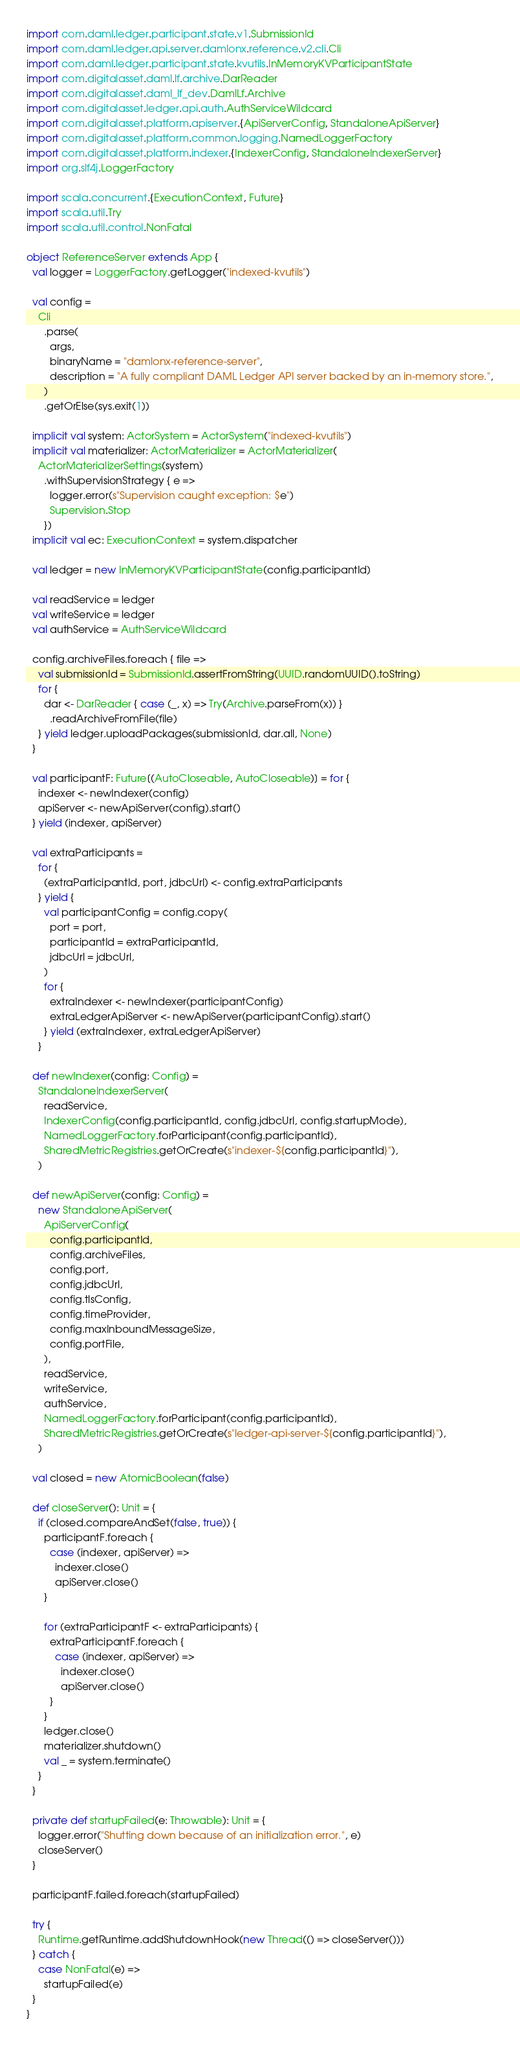Convert code to text. <code><loc_0><loc_0><loc_500><loc_500><_Scala_>import com.daml.ledger.participant.state.v1.SubmissionId
import com.daml.ledger.api.server.damlonx.reference.v2.cli.Cli
import com.daml.ledger.participant.state.kvutils.InMemoryKVParticipantState
import com.digitalasset.daml.lf.archive.DarReader
import com.digitalasset.daml_lf_dev.DamlLf.Archive
import com.digitalasset.ledger.api.auth.AuthServiceWildcard
import com.digitalasset.platform.apiserver.{ApiServerConfig, StandaloneApiServer}
import com.digitalasset.platform.common.logging.NamedLoggerFactory
import com.digitalasset.platform.indexer.{IndexerConfig, StandaloneIndexerServer}
import org.slf4j.LoggerFactory

import scala.concurrent.{ExecutionContext, Future}
import scala.util.Try
import scala.util.control.NonFatal

object ReferenceServer extends App {
  val logger = LoggerFactory.getLogger("indexed-kvutils")

  val config =
    Cli
      .parse(
        args,
        binaryName = "damlonx-reference-server",
        description = "A fully compliant DAML Ledger API server backed by an in-memory store.",
      )
      .getOrElse(sys.exit(1))

  implicit val system: ActorSystem = ActorSystem("indexed-kvutils")
  implicit val materializer: ActorMaterializer = ActorMaterializer(
    ActorMaterializerSettings(system)
      .withSupervisionStrategy { e =>
        logger.error(s"Supervision caught exception: $e")
        Supervision.Stop
      })
  implicit val ec: ExecutionContext = system.dispatcher

  val ledger = new InMemoryKVParticipantState(config.participantId)

  val readService = ledger
  val writeService = ledger
  val authService = AuthServiceWildcard

  config.archiveFiles.foreach { file =>
    val submissionId = SubmissionId.assertFromString(UUID.randomUUID().toString)
    for {
      dar <- DarReader { case (_, x) => Try(Archive.parseFrom(x)) }
        .readArchiveFromFile(file)
    } yield ledger.uploadPackages(submissionId, dar.all, None)
  }

  val participantF: Future[(AutoCloseable, AutoCloseable)] = for {
    indexer <- newIndexer(config)
    apiServer <- newApiServer(config).start()
  } yield (indexer, apiServer)

  val extraParticipants =
    for {
      (extraParticipantId, port, jdbcUrl) <- config.extraParticipants
    } yield {
      val participantConfig = config.copy(
        port = port,
        participantId = extraParticipantId,
        jdbcUrl = jdbcUrl,
      )
      for {
        extraIndexer <- newIndexer(participantConfig)
        extraLedgerApiServer <- newApiServer(participantConfig).start()
      } yield (extraIndexer, extraLedgerApiServer)
    }

  def newIndexer(config: Config) =
    StandaloneIndexerServer(
      readService,
      IndexerConfig(config.participantId, config.jdbcUrl, config.startupMode),
      NamedLoggerFactory.forParticipant(config.participantId),
      SharedMetricRegistries.getOrCreate(s"indexer-${config.participantId}"),
    )

  def newApiServer(config: Config) =
    new StandaloneApiServer(
      ApiServerConfig(
        config.participantId,
        config.archiveFiles,
        config.port,
        config.jdbcUrl,
        config.tlsConfig,
        config.timeProvider,
        config.maxInboundMessageSize,
        config.portFile,
      ),
      readService,
      writeService,
      authService,
      NamedLoggerFactory.forParticipant(config.participantId),
      SharedMetricRegistries.getOrCreate(s"ledger-api-server-${config.participantId}"),
    )

  val closed = new AtomicBoolean(false)

  def closeServer(): Unit = {
    if (closed.compareAndSet(false, true)) {
      participantF.foreach {
        case (indexer, apiServer) =>
          indexer.close()
          apiServer.close()
      }

      for (extraParticipantF <- extraParticipants) {
        extraParticipantF.foreach {
          case (indexer, apiServer) =>
            indexer.close()
            apiServer.close()
        }
      }
      ledger.close()
      materializer.shutdown()
      val _ = system.terminate()
    }
  }

  private def startupFailed(e: Throwable): Unit = {
    logger.error("Shutting down because of an initialization error.", e)
    closeServer()
  }

  participantF.failed.foreach(startupFailed)

  try {
    Runtime.getRuntime.addShutdownHook(new Thread(() => closeServer()))
  } catch {
    case NonFatal(e) =>
      startupFailed(e)
  }
}
</code> 